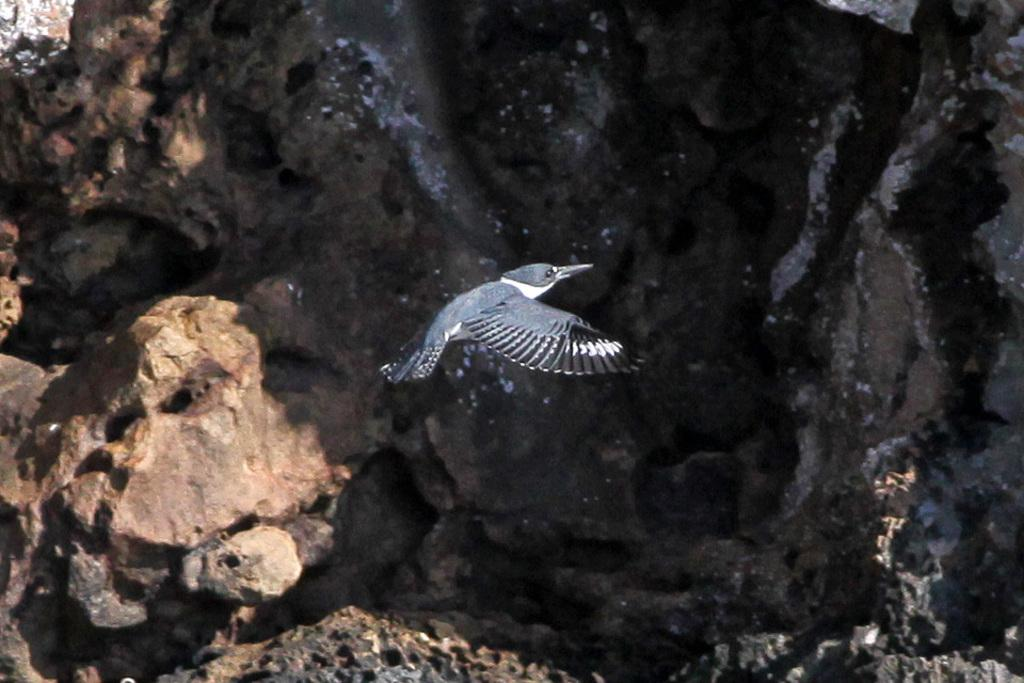What is the main subject in the center of the image? There is a bird in the center of the image. What can be seen in the background of the image? There is a rock in the background of the image. How many oranges did the daughter bring to the scene in the image? There is no daughter or oranges present in the image. 